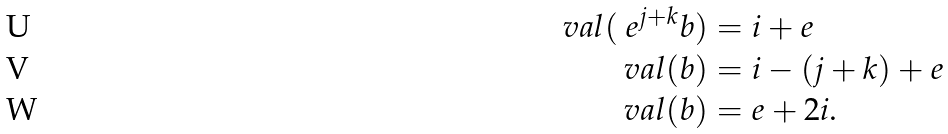<formula> <loc_0><loc_0><loc_500><loc_500>\ v a l ( \ e ^ { j + k } b ) & = i + e \\ \ v a l ( b ) & = i - ( j + k ) + e \\ \ v a l ( b ) & = e + 2 i .</formula> 